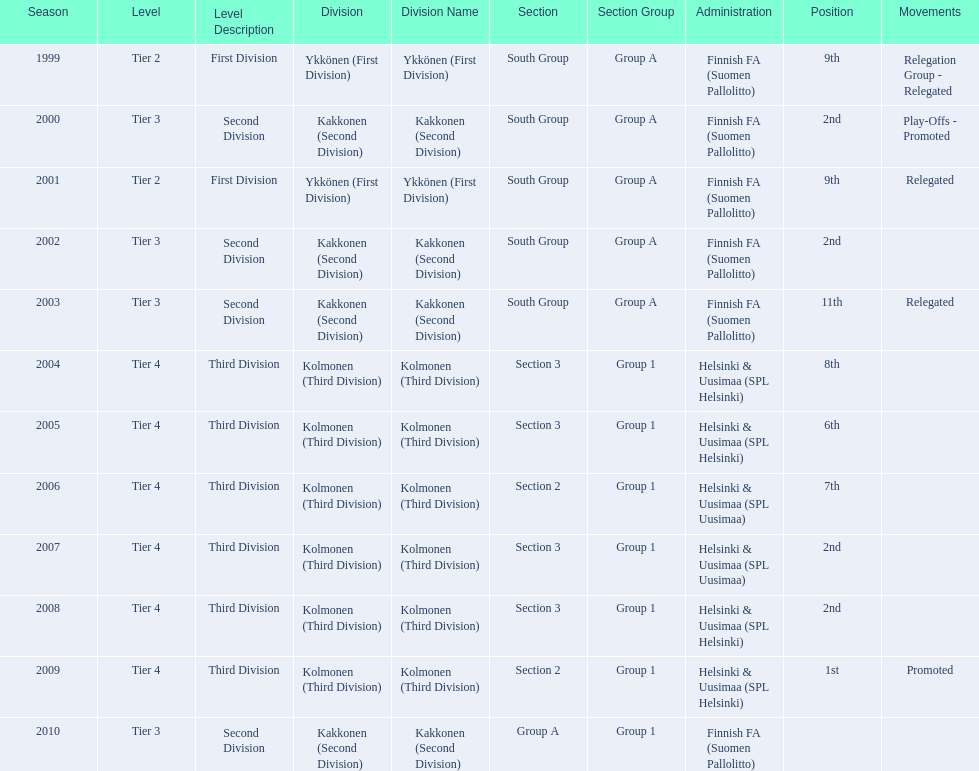Which administration has the least amount of division? Helsinki & Uusimaa (SPL Helsinki). 